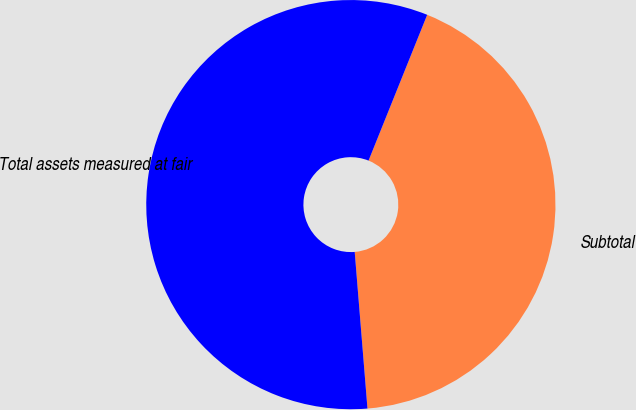Convert chart. <chart><loc_0><loc_0><loc_500><loc_500><pie_chart><fcel>Subtotal<fcel>Total assets measured at fair<nl><fcel>42.62%<fcel>57.38%<nl></chart> 